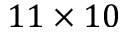<formula> <loc_0><loc_0><loc_500><loc_500>1 1 \times 1 0</formula> 